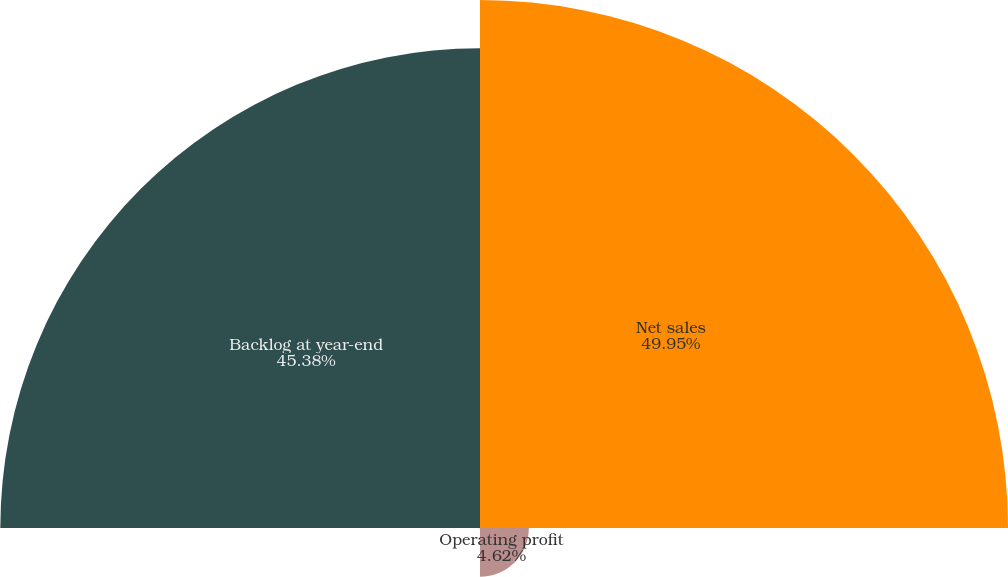Convert chart to OTSL. <chart><loc_0><loc_0><loc_500><loc_500><pie_chart><fcel>Net sales<fcel>Operating profit<fcel>Operating margins<fcel>Backlog at year-end<nl><fcel>49.95%<fcel>4.62%<fcel>0.05%<fcel>45.38%<nl></chart> 